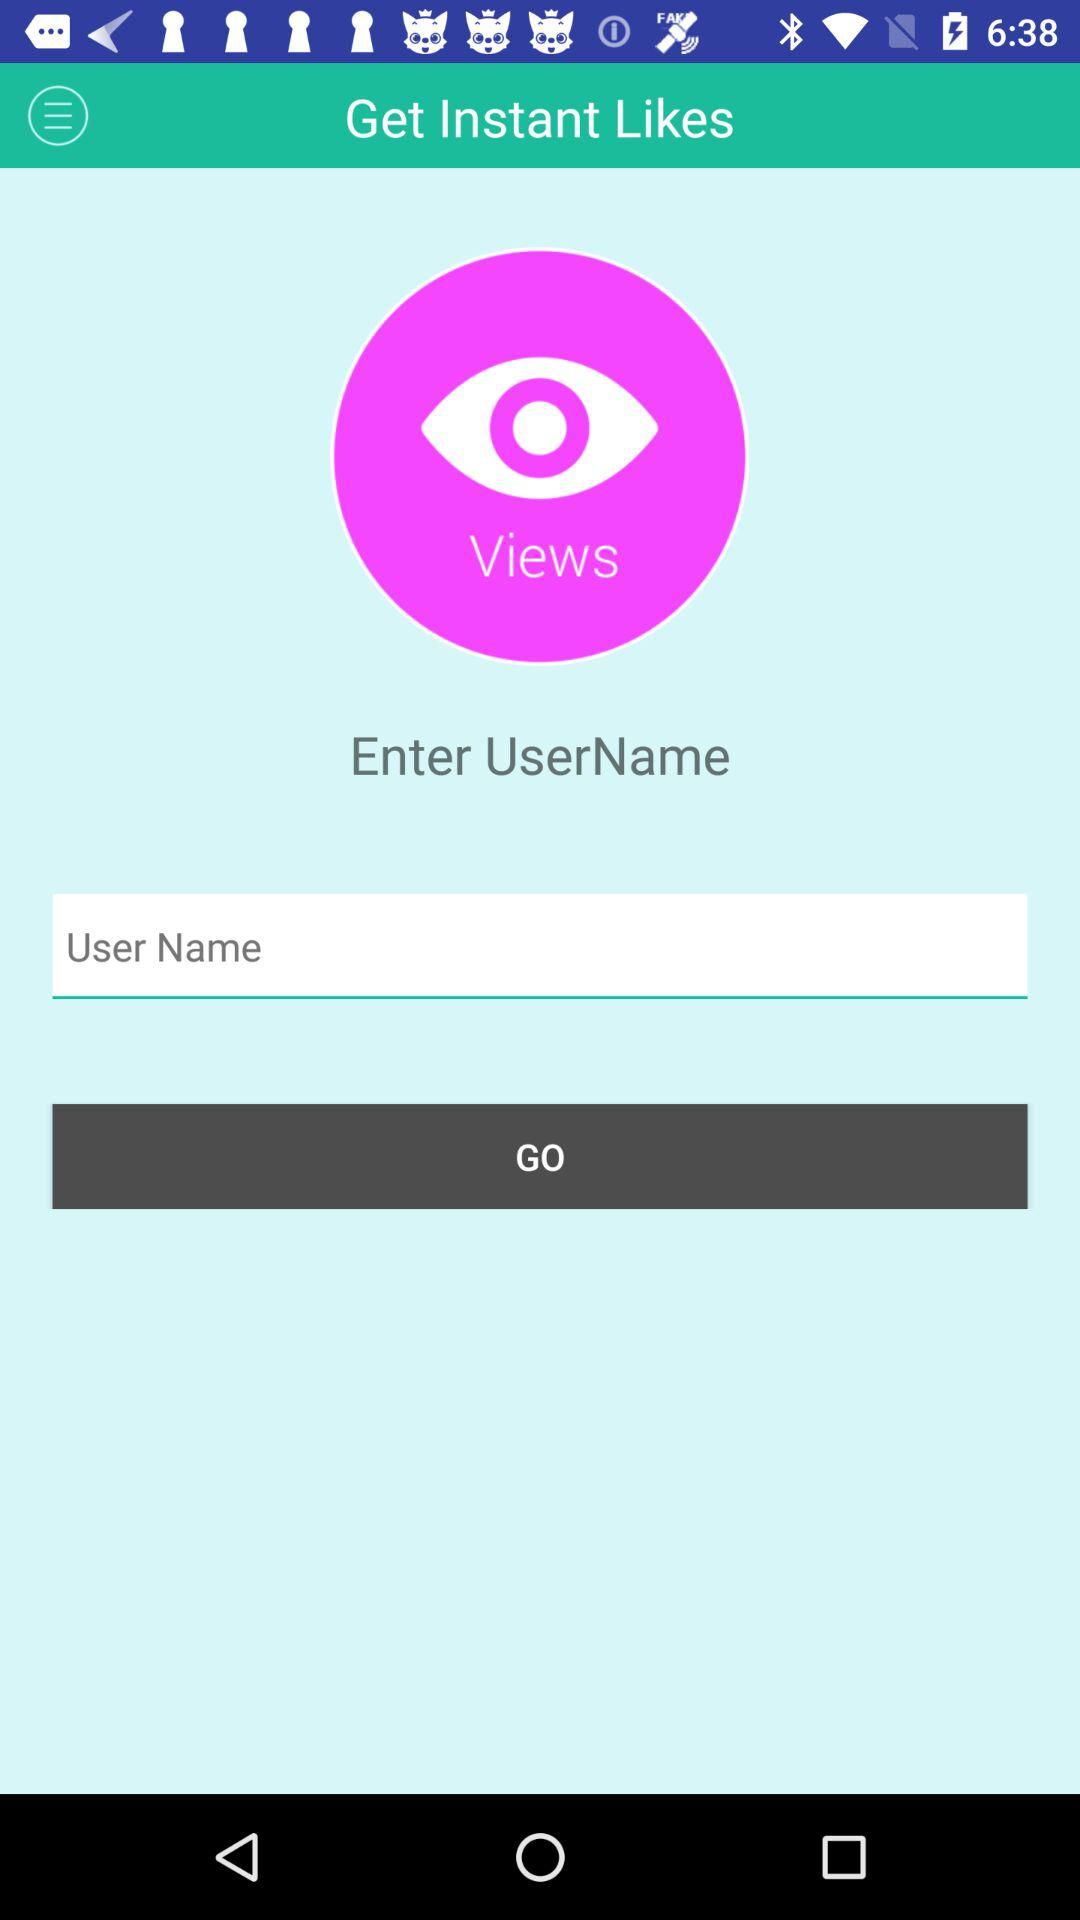Can we check views?
When the provided information is insufficient, respond with <no answer>. <no answer> 